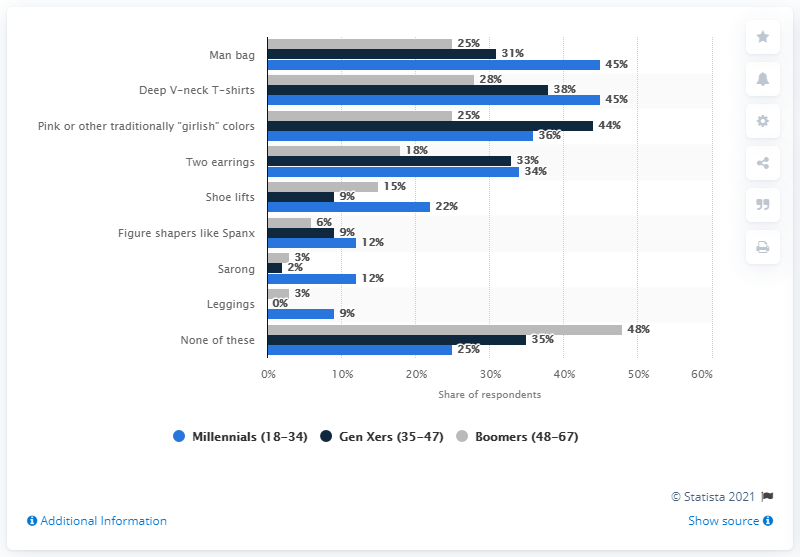Highlight a few significant elements in this photo. A significant percentage of Millennials accept leggings as a fashionable item. The product of the shortest gray bar and the longest blue bar is 135. 